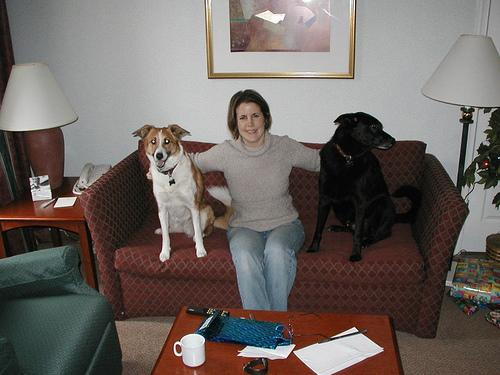Mention the item placed on the end table and its color. A white lamp shade is situated atop a lamp on the end table. Identify the animal sitting in the foreground, its color and any accessories it may be wearing. A black dog with a brown collar is sitting on the couch. Explain which type of seating furniture is placed in proximity to the center table. A green recliner is situated beside the center table in the living room. Specify the type of beverage container that is placed on the table and its color. A white coffee mug is sitting on the coffee table. In a few words, tell me what is the primary human figure doing in the image. A woman with brown hair is sitting with two dogs on a maroon couch. What type of electronic device is located on the coffee table? A black television remote control sits atop the coffee table. Point out the optical accessory positioned on the center table. Eyeglasses are placed on the center table. Elaborate on the design and color of the couch in the image. There is a maroon couch with a red and gold pattern, perfect for sitting and relaxing. Tell me the color and theme of the gift bag on the table. An empty blue gift bag with a festive design is placed on the table. 